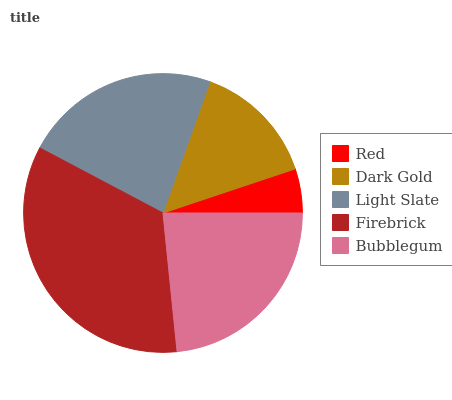Is Red the minimum?
Answer yes or no. Yes. Is Firebrick the maximum?
Answer yes or no. Yes. Is Dark Gold the minimum?
Answer yes or no. No. Is Dark Gold the maximum?
Answer yes or no. No. Is Dark Gold greater than Red?
Answer yes or no. Yes. Is Red less than Dark Gold?
Answer yes or no. Yes. Is Red greater than Dark Gold?
Answer yes or no. No. Is Dark Gold less than Red?
Answer yes or no. No. Is Light Slate the high median?
Answer yes or no. Yes. Is Light Slate the low median?
Answer yes or no. Yes. Is Firebrick the high median?
Answer yes or no. No. Is Dark Gold the low median?
Answer yes or no. No. 